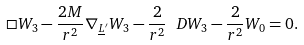<formula> <loc_0><loc_0><loc_500><loc_500>\Box W _ { 3 } - \frac { 2 M } { r ^ { 2 } } \nabla _ { \underline { L } ^ { \prime } } W _ { 3 } - \frac { 2 } { r ^ { 2 } } \ D W _ { 3 } - \frac { 2 } { r ^ { 2 } } W _ { 0 } = 0 .</formula> 